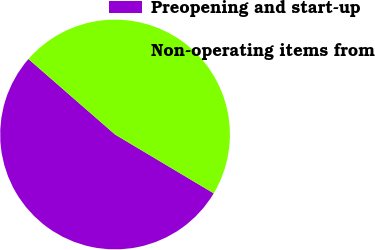<chart> <loc_0><loc_0><loc_500><loc_500><pie_chart><fcel>Preopening and start-up<fcel>Non-operating items from<nl><fcel>52.85%<fcel>47.15%<nl></chart> 